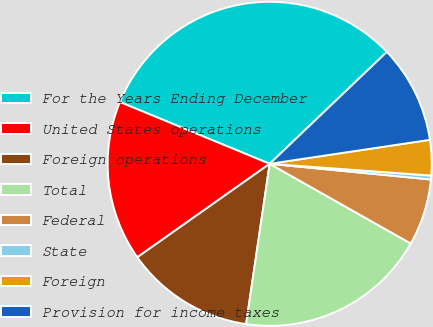<chart> <loc_0><loc_0><loc_500><loc_500><pie_chart><fcel>For the Years Ending December<fcel>United States operations<fcel>Foreign operations<fcel>Total<fcel>Federal<fcel>State<fcel>Foreign<fcel>Provision for income taxes<nl><fcel>31.64%<fcel>16.01%<fcel>12.89%<fcel>19.14%<fcel>6.64%<fcel>0.39%<fcel>3.52%<fcel>9.77%<nl></chart> 